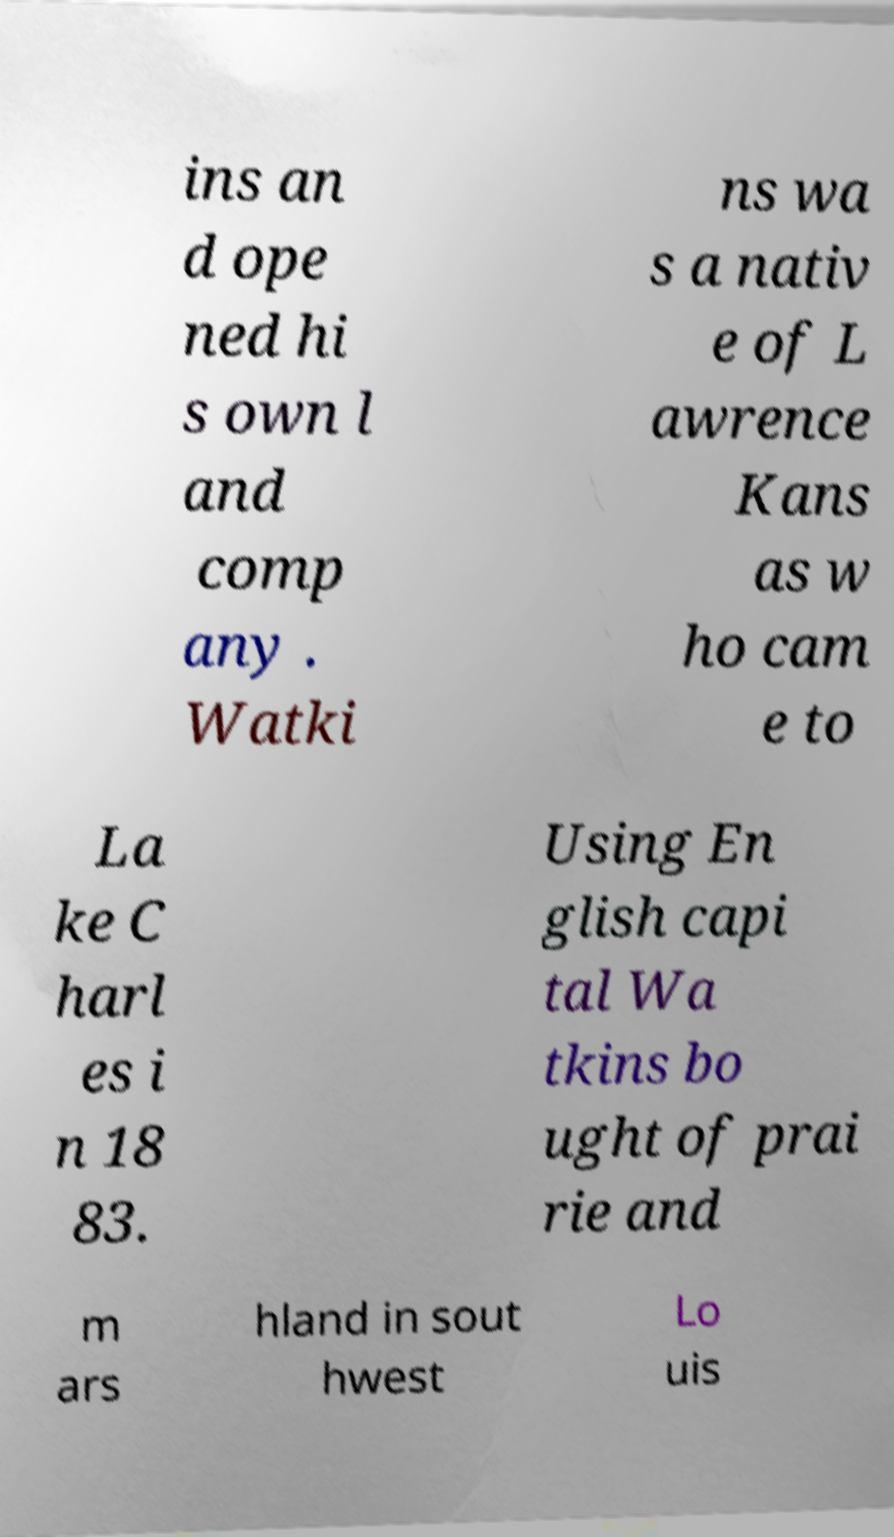Please read and relay the text visible in this image. What does it say? ins an d ope ned hi s own l and comp any . Watki ns wa s a nativ e of L awrence Kans as w ho cam e to La ke C harl es i n 18 83. Using En glish capi tal Wa tkins bo ught of prai rie and m ars hland in sout hwest Lo uis 